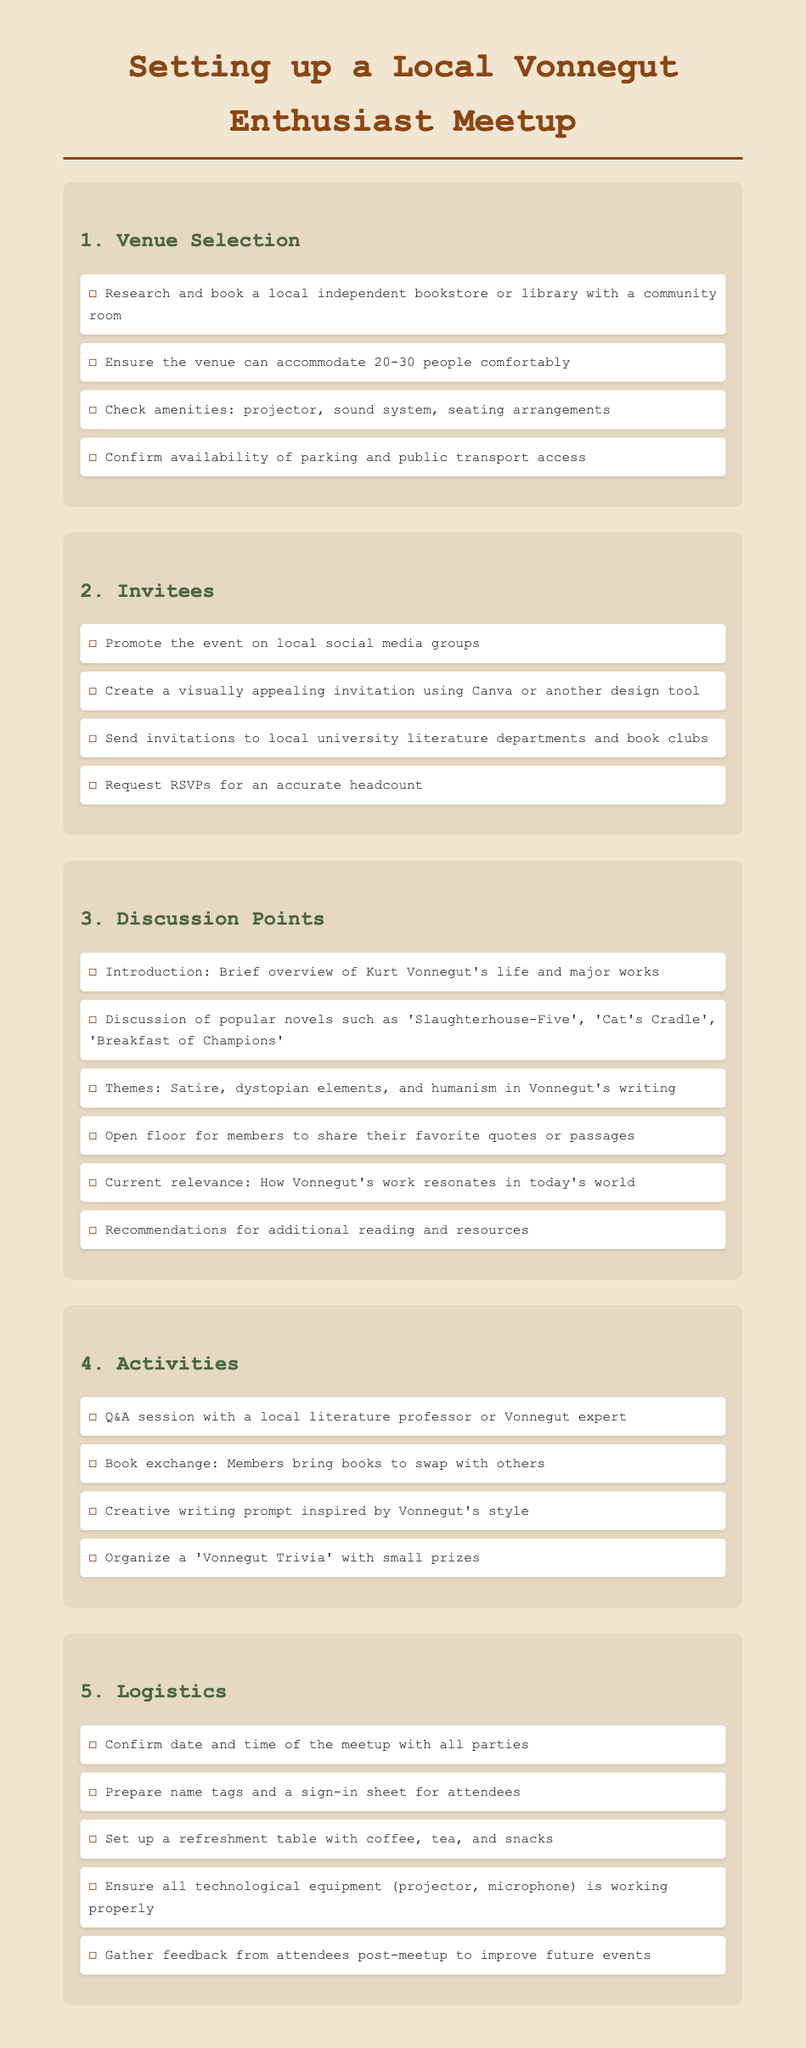what is the maximum number of people the venue should accommodate? The document states that the venue should accommodate between 20 to 30 people.
Answer: 20-30 what are the recommended social media platforms for promoting the event? The document mentions promoting the event on local social media groups.
Answer: Local social media groups how many discussion points are listed in the checklist? The document enumerates multiple discussion points under the section, totaling six specific points.
Answer: 6 what is one activity suggested for the meetup? The document lists several activities, one of which includes a Q&A session with a local literature professor.
Answer: Q&A session which Kurt Vonnegut novel is mentioned first in the discussion points? The first novel mentioned in the discussion points is 'Slaughterhouse-Five'.
Answer: Slaughterhouse-Five what should be prepared for attendees at the refreshment table? The document indicates that coffee, tea, and snacks should be provided at the refreshment table.
Answer: Coffee, tea, and snacks how should RSVPs be handled according to the document? The document suggests requesting RSVPs to attain an accurate headcount for the event.
Answer: Request RSVPs what type of room is preferred for the venue? It is suggested to book a community room in a bookstore or library for the venue.
Answer: Community room 